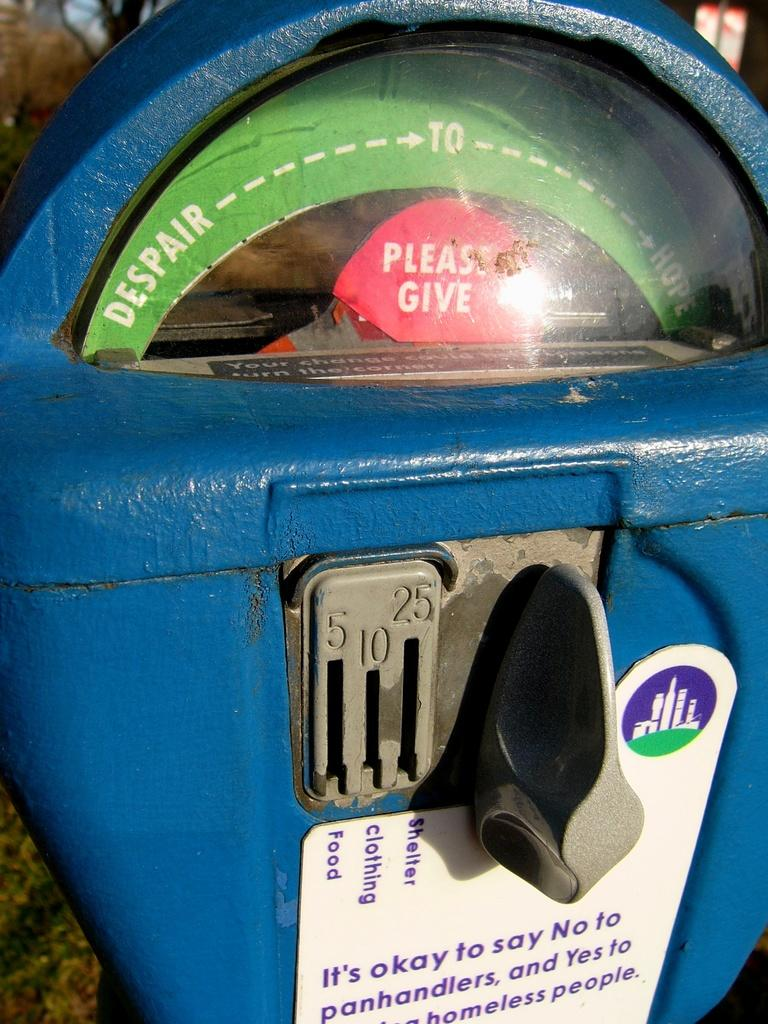<image>
Relay a brief, clear account of the picture shown. A blue coin machine with a red tab saying Please Give and different coin slots 